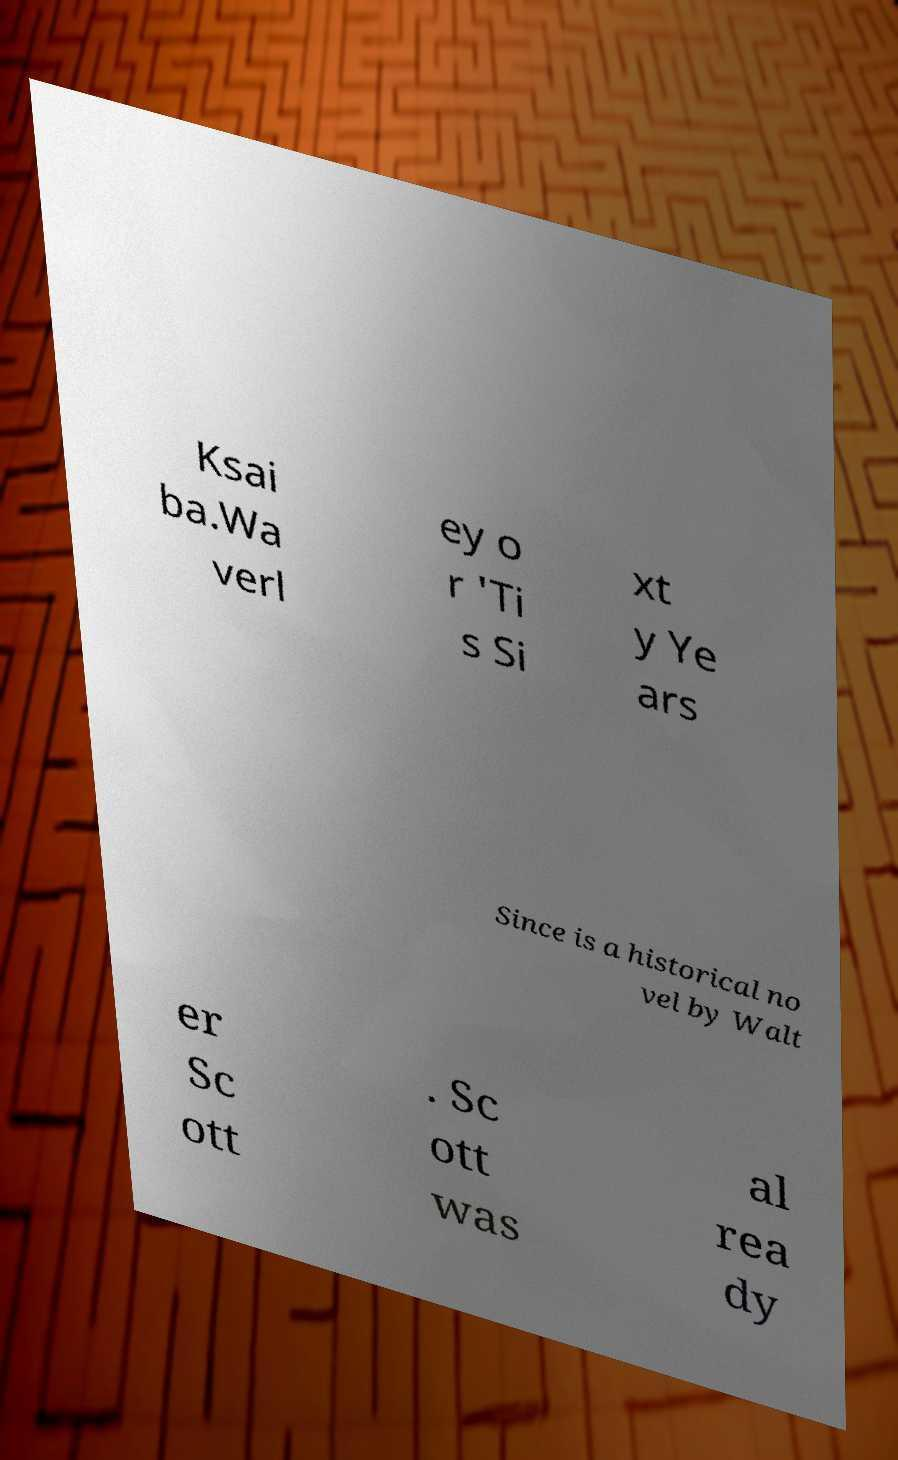Could you extract and type out the text from this image? Ksai ba.Wa verl ey o r 'Ti s Si xt y Ye ars Since is a historical no vel by Walt er Sc ott . Sc ott was al rea dy 